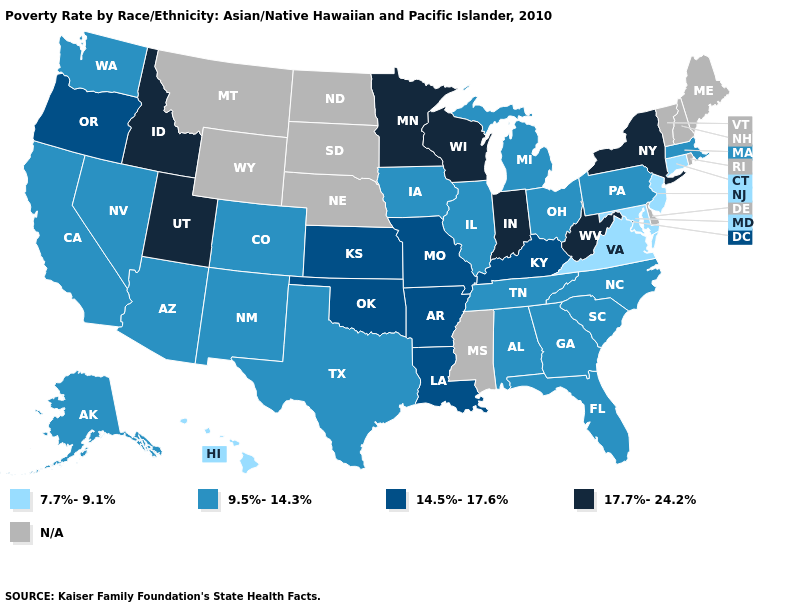What is the value of Kansas?
Be succinct. 14.5%-17.6%. Which states have the highest value in the USA?
Quick response, please. Idaho, Indiana, Minnesota, New York, Utah, West Virginia, Wisconsin. Which states hav the highest value in the Northeast?
Short answer required. New York. Does West Virginia have the lowest value in the South?
Keep it brief. No. Does the first symbol in the legend represent the smallest category?
Quick response, please. Yes. Which states have the lowest value in the South?
Concise answer only. Maryland, Virginia. Among the states that border Utah , which have the lowest value?
Concise answer only. Arizona, Colorado, Nevada, New Mexico. Does New Jersey have the highest value in the Northeast?
Short answer required. No. Name the states that have a value in the range 7.7%-9.1%?
Be succinct. Connecticut, Hawaii, Maryland, New Jersey, Virginia. Among the states that border Montana , which have the highest value?
Be succinct. Idaho. What is the value of North Dakota?
Write a very short answer. N/A. Among the states that border North Carolina , which have the lowest value?
Quick response, please. Virginia. How many symbols are there in the legend?
Give a very brief answer. 5. What is the value of Oregon?
Write a very short answer. 14.5%-17.6%. 